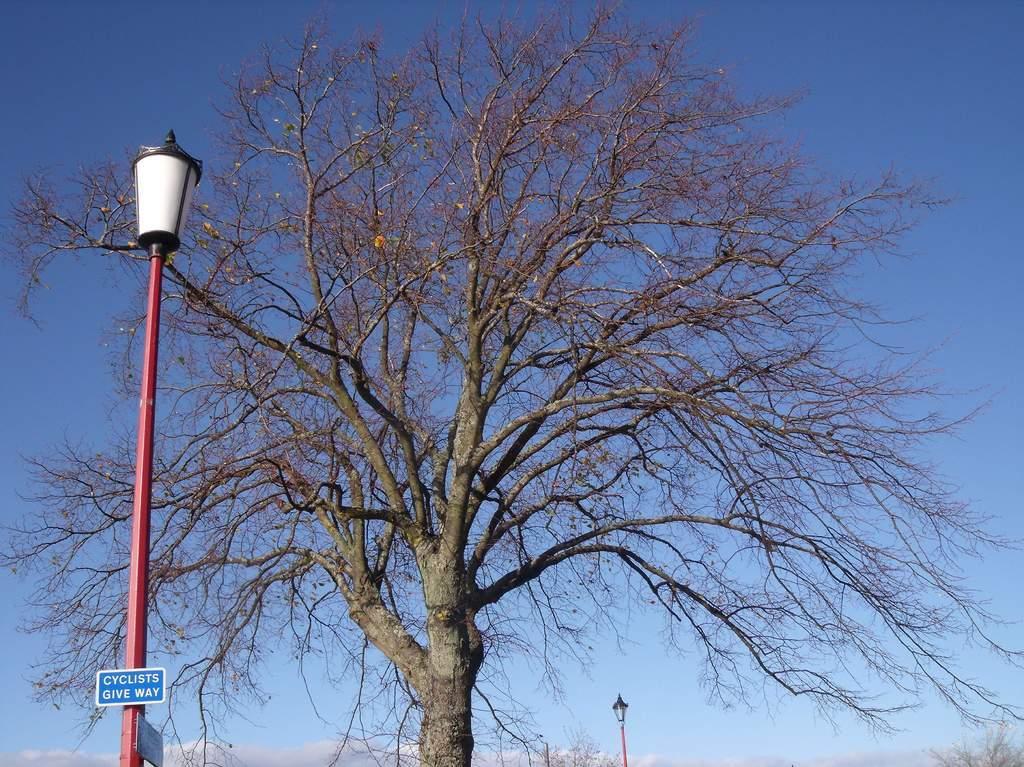Describe this image in one or two sentences. In the picture I can see trees, pole lights and a blue color board which has something written on it. In the background I can see the sky. 